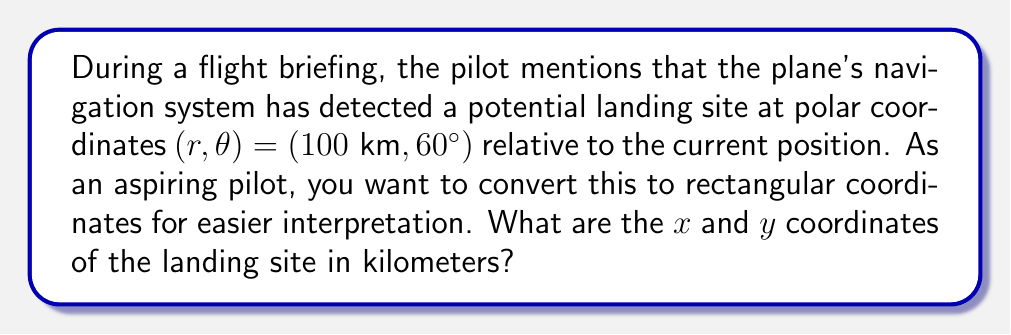Give your solution to this math problem. To convert from polar coordinates $(r, \theta)$ to rectangular coordinates $(x, y)$, we use the following formulas:

$$x = r \cos(\theta)$$
$$y = r \sin(\theta)$$

Given:
$r = 100 \text{ km}$
$\theta = 60°$

Step 1: Calculate $x$
$$x = r \cos(\theta)$$
$$x = 100 \cos(60°)$$
$$x = 100 \cdot 0.5 = 50 \text{ km}$$

Step 2: Calculate $y$
$$y = r \sin(\theta)$$
$$y = 100 \sin(60°)$$
$$y = 100 \cdot \frac{\sqrt{3}}{2} \approx 86.60 \text{ km}$$

Therefore, the rectangular coordinates of the landing site are approximately $(50 \text{ km}, 86.60 \text{ km})$.

[asy]
import geometry;

size(200);
real r = 5;
real theta = pi/3;

draw((-1,0)--(7,0), arrow=Arrow(TeXHead));
draw((0,-1)--(0,7), arrow=Arrow(TeXHead));

draw((0,0)--(r*cos(theta), r*sin(theta)), arrow=Arrow(TeXHead), blue);
draw(arc((0,0), 1.5, 0, degrees(theta)), L=Label("60°", position=MidPoint));

dot((r*cos(theta), r*sin(theta)), blue);
label("(50, 86.60)", (r*cos(theta), r*sin(theta)), NE);

label("x", (7,0), E);
label("y", (0,7), N);
[/asy]
Answer: $(50 \text{ km}, 86.60 \text{ km})$ 